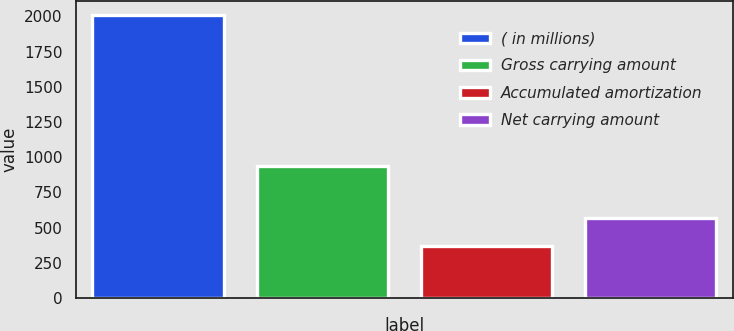<chart> <loc_0><loc_0><loc_500><loc_500><bar_chart><fcel>( in millions)<fcel>Gross carrying amount<fcel>Accumulated amortization<fcel>Net carrying amount<nl><fcel>2011<fcel>939<fcel>372<fcel>567<nl></chart> 